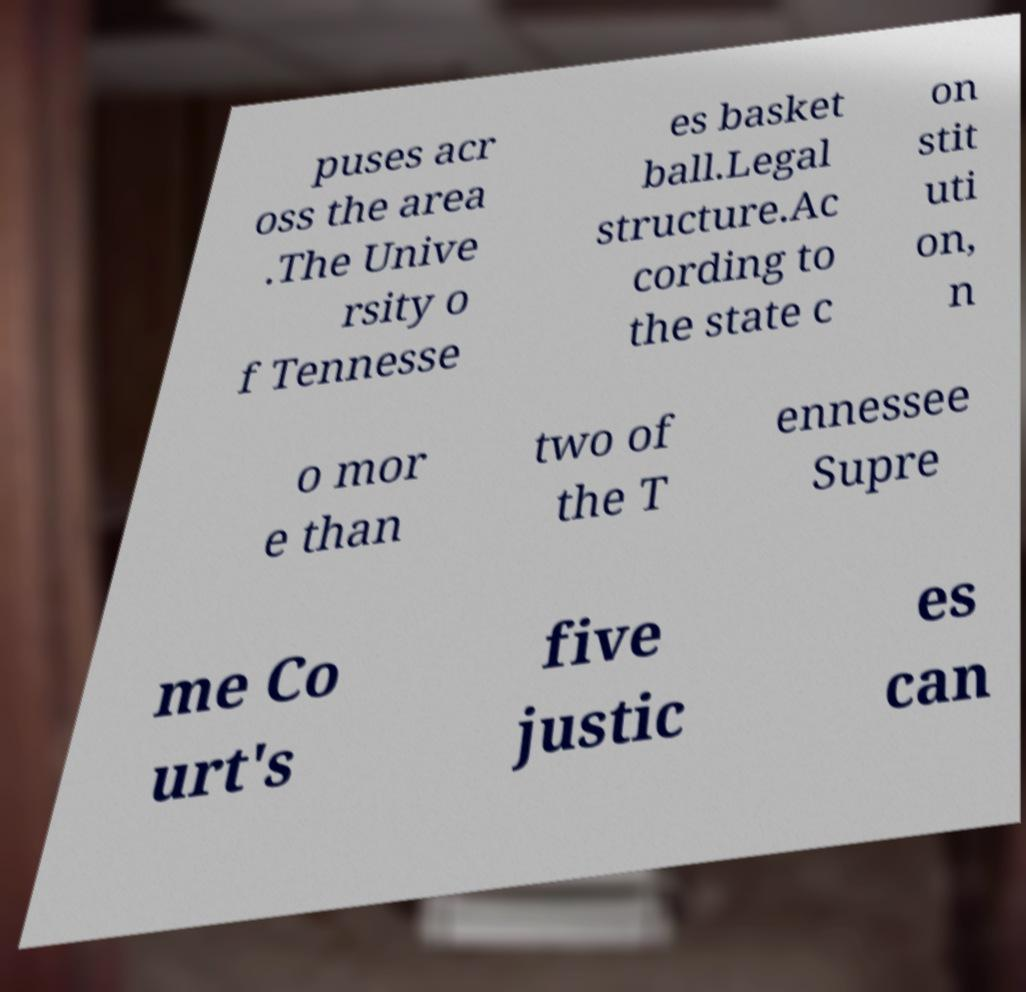What messages or text are displayed in this image? I need them in a readable, typed format. puses acr oss the area .The Unive rsity o f Tennesse es basket ball.Legal structure.Ac cording to the state c on stit uti on, n o mor e than two of the T ennessee Supre me Co urt's five justic es can 